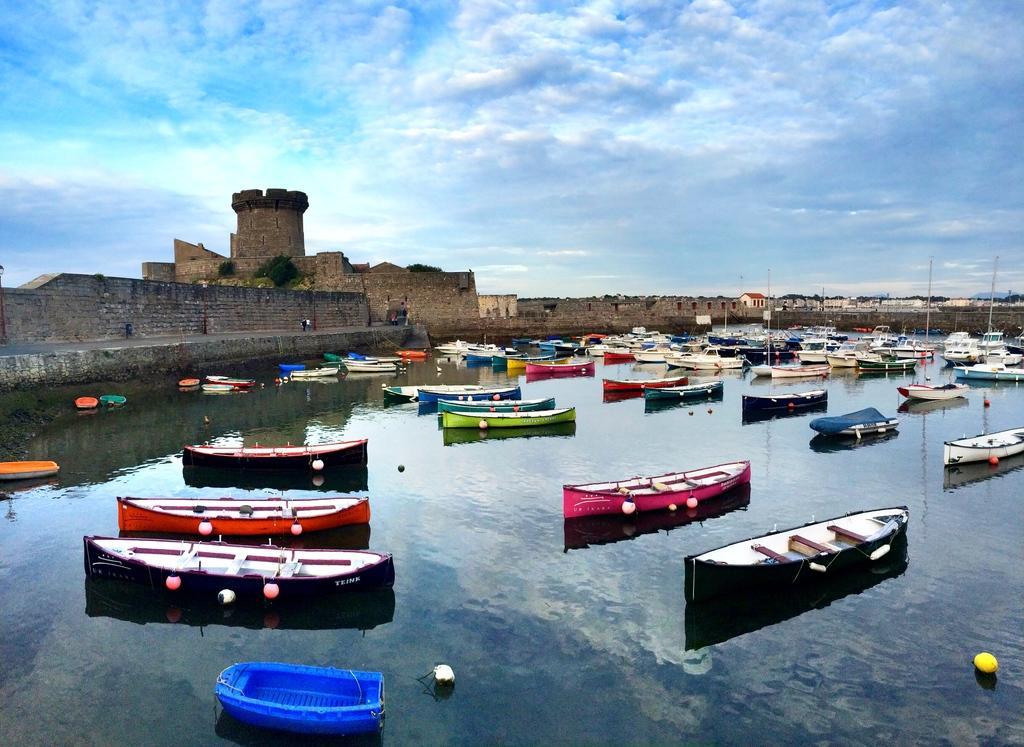How would you summarize this image in a sentence or two? In this image, we can see few boats are above the water. Background we can see houses, trees, walls and fort. Here we can see the cloudy sky. On the left side of the image, it looks like a person is standing on the walkway. 